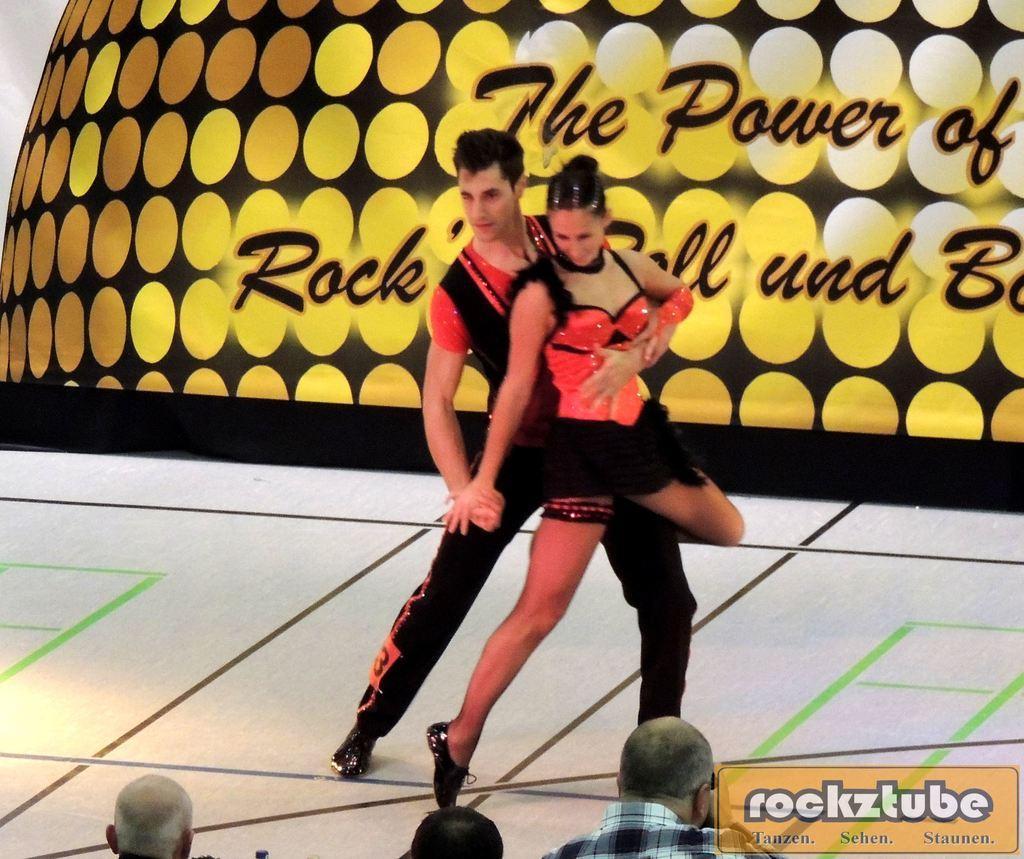In one or two sentences, can you explain what this image depicts? In the picture I can see a man and a woman are standing together. In the background I can see something displaying on the screen. In the front I can see people and a watermark on the image. 